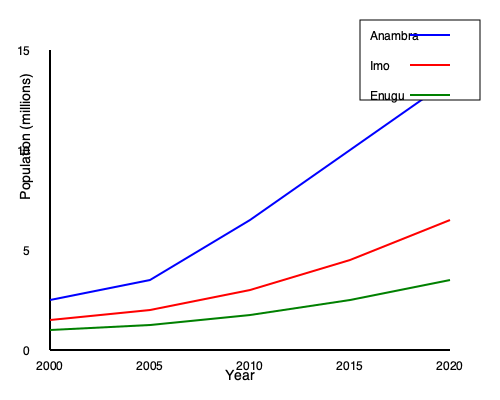Based on the line graph showing population growth in three Igbo-speaking states from 2000 to 2020, which state experienced the most rapid population growth, and what factors might contribute to this trend? To determine which state experienced the most rapid population growth, we need to analyze the slopes of the lines for each state:

1. Anambra (blue line):
   - Starts at about 4 million in 2000
   - Ends at about 13.5 million in 2020
   - Steepest slope among the three lines

2. Imo (red line):
   - Starts at about 3 million in 2000
   - Ends at about 8 million in 2020
   - Moderate slope

3. Enugu (green line):
   - Starts at about 2 million in 2000
   - Ends at about 5 million in 2020
   - Least steep slope

Anambra shows the steepest slope, indicating the most rapid population growth.

Factors contributing to this trend may include:

1. Economic development: Anambra might have experienced more rapid industrialization or economic growth, attracting more people to the state.

2. Urbanization: Faster urban development in Anambra could lead to increased migration from rural areas.

3. Higher birth rates: Cultural or socioeconomic factors might contribute to higher fertility rates in Anambra.

4. Lower emigration rates: Anambra might have better job opportunities or living conditions, encouraging people to stay.

5. Government policies: Anambra's policies might be more favorable for population growth or attract more people to the state.

6. Healthcare improvements: Better healthcare facilities could lead to lower mortality rates and higher life expectancy.

7. Educational opportunities: More educational institutions might attract students and young professionals.

These factors, individually or in combination, could explain Anambra's rapid population growth compared to Imo and Enugu.
Answer: Anambra experienced the most rapid population growth, likely due to factors such as economic development, urbanization, and favorable government policies. 